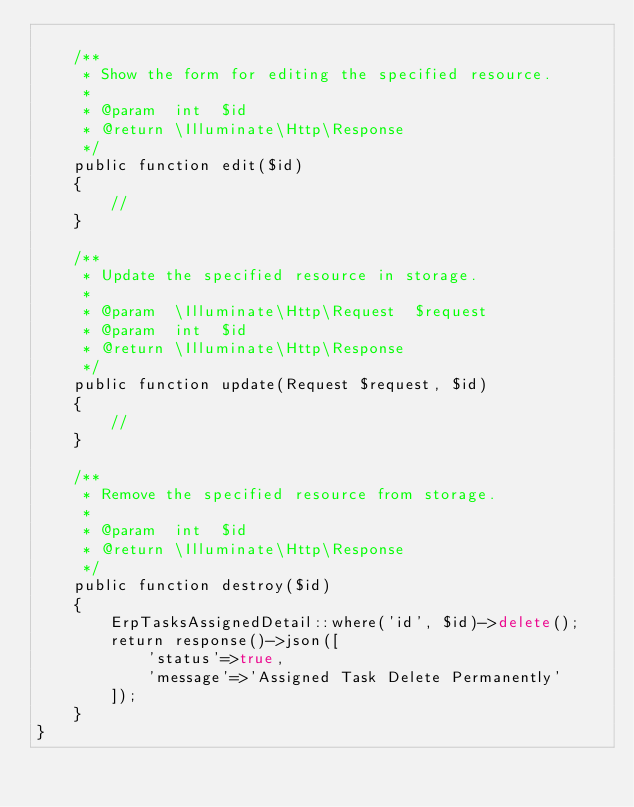<code> <loc_0><loc_0><loc_500><loc_500><_PHP_>
    /**
     * Show the form for editing the specified resource.
     *
     * @param  int  $id
     * @return \Illuminate\Http\Response
     */
    public function edit($id)
    {
        //
    }

    /**
     * Update the specified resource in storage.
     *
     * @param  \Illuminate\Http\Request  $request
     * @param  int  $id
     * @return \Illuminate\Http\Response
     */
    public function update(Request $request, $id)
    {
        //
    }

    /**
     * Remove the specified resource from storage.
     *
     * @param  int  $id
     * @return \Illuminate\Http\Response
     */
    public function destroy($id)
    {
        ErpTasksAssignedDetail::where('id', $id)->delete();
        return response()->json([
            'status'=>true,
            'message'=>'Assigned Task Delete Permanently'
        ]);
    }
}
</code> 